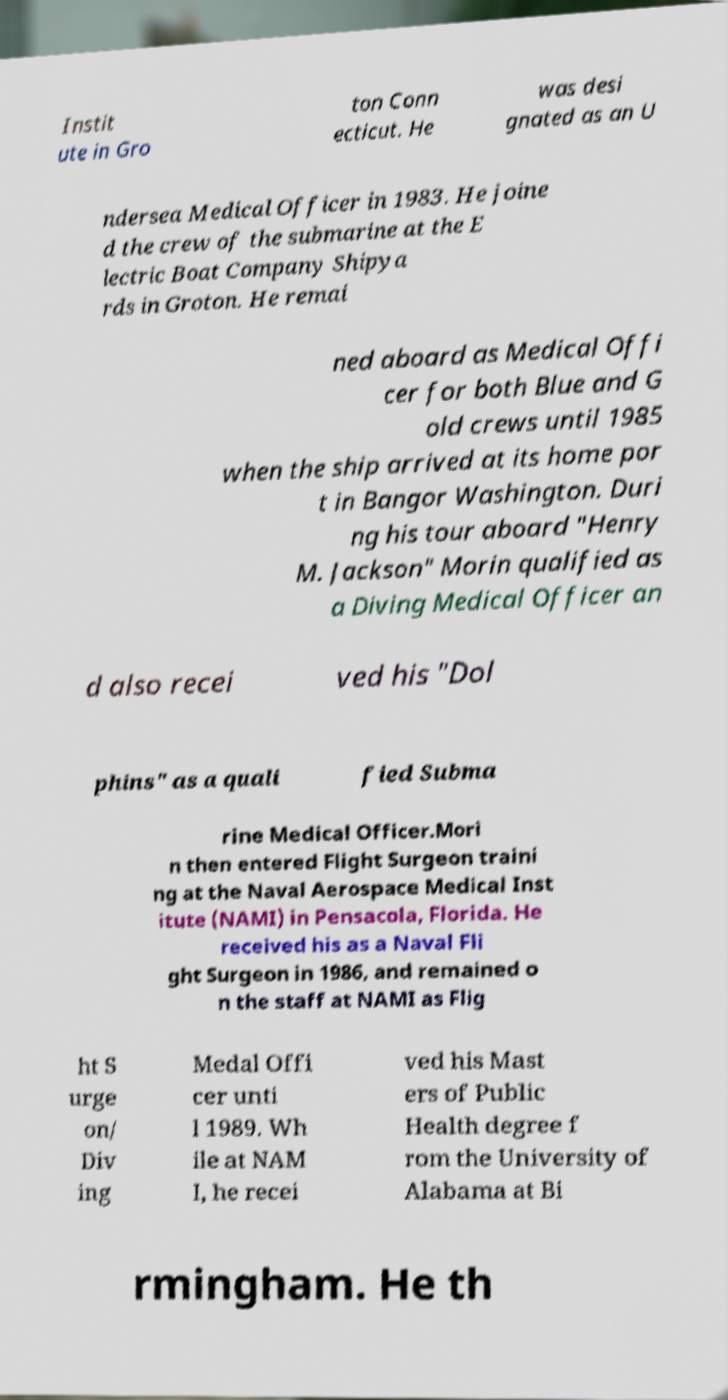For documentation purposes, I need the text within this image transcribed. Could you provide that? Instit ute in Gro ton Conn ecticut. He was desi gnated as an U ndersea Medical Officer in 1983. He joine d the crew of the submarine at the E lectric Boat Company Shipya rds in Groton. He remai ned aboard as Medical Offi cer for both Blue and G old crews until 1985 when the ship arrived at its home por t in Bangor Washington. Duri ng his tour aboard "Henry M. Jackson" Morin qualified as a Diving Medical Officer an d also recei ved his "Dol phins" as a quali fied Subma rine Medical Officer.Mori n then entered Flight Surgeon traini ng at the Naval Aerospace Medical Inst itute (NAMI) in Pensacola, Florida. He received his as a Naval Fli ght Surgeon in 1986, and remained o n the staff at NAMI as Flig ht S urge on/ Div ing Medal Offi cer unti l 1989. Wh ile at NAM I, he recei ved his Mast ers of Public Health degree f rom the University of Alabama at Bi rmingham. He th 